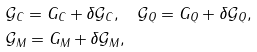Convert formula to latex. <formula><loc_0><loc_0><loc_500><loc_500>& \mathcal { G } _ { C } = G _ { C } + \delta \mathcal { G } _ { C } , \quad \mathcal { G } _ { Q } = G _ { Q } + \delta \mathcal { G } _ { Q } , \\ & \mathcal { G } _ { M } = G _ { M } + \delta \mathcal { G } _ { M } ,</formula> 